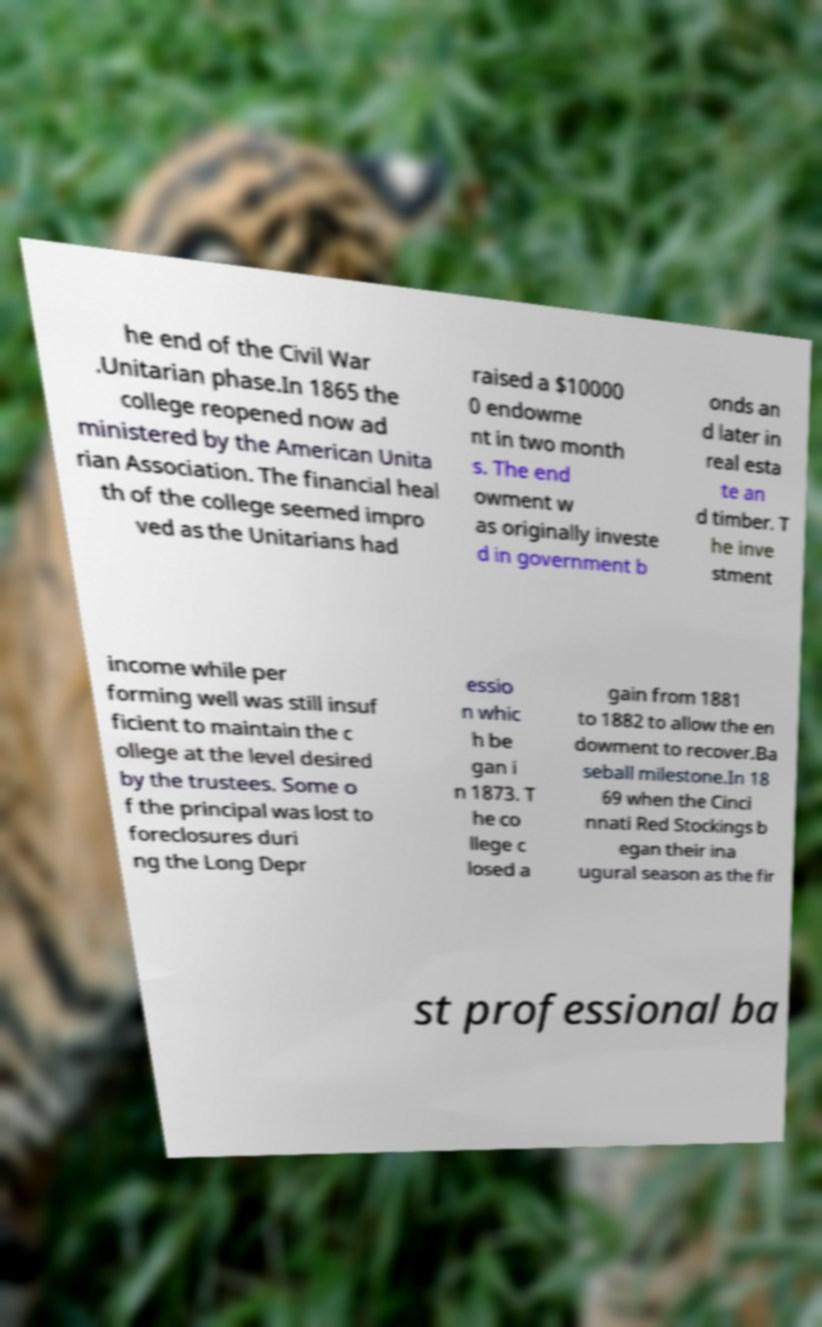Please identify and transcribe the text found in this image. he end of the Civil War .Unitarian phase.In 1865 the college reopened now ad ministered by the American Unita rian Association. The financial heal th of the college seemed impro ved as the Unitarians had raised a $10000 0 endowme nt in two month s. The end owment w as originally investe d in government b onds an d later in real esta te an d timber. T he inve stment income while per forming well was still insuf ficient to maintain the c ollege at the level desired by the trustees. Some o f the principal was lost to foreclosures duri ng the Long Depr essio n whic h be gan i n 1873. T he co llege c losed a gain from 1881 to 1882 to allow the en dowment to recover.Ba seball milestone.In 18 69 when the Cinci nnati Red Stockings b egan their ina ugural season as the fir st professional ba 